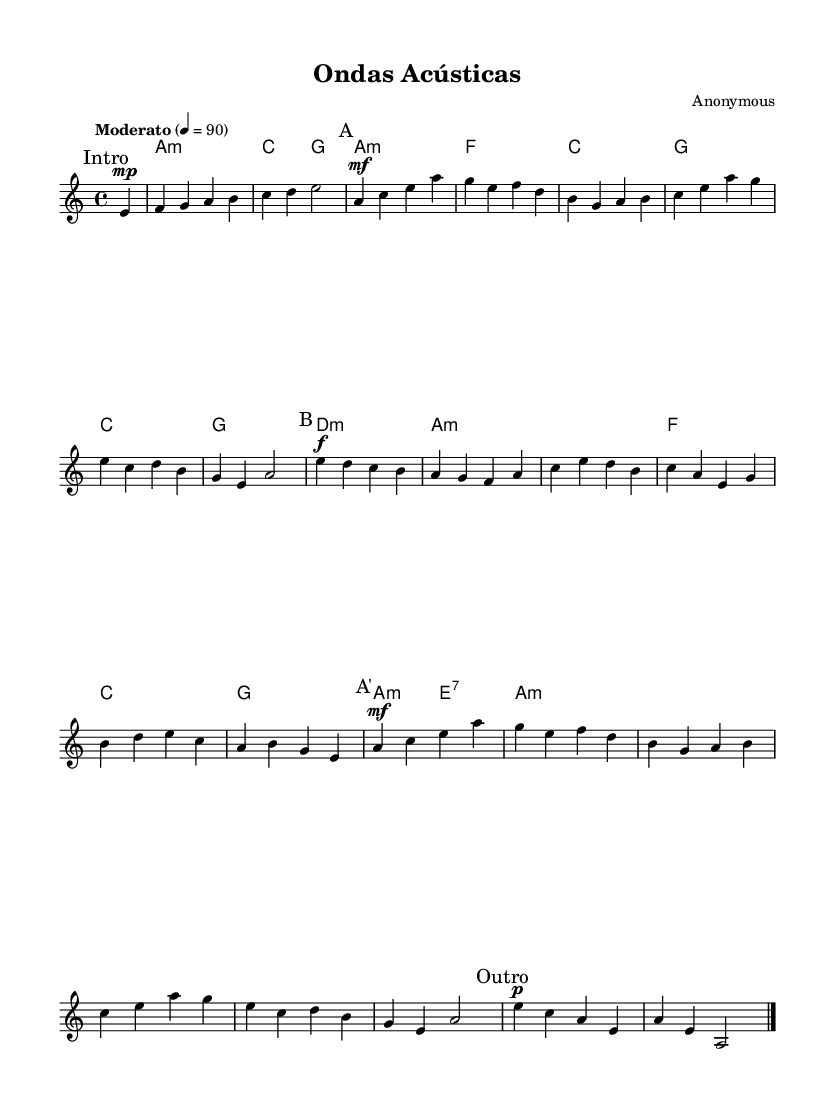What is the key signature of this music? The key signature is indicated by the use of 'a' and 'a minor' chords. There are no sharps or flats noted, confirming it is in a natural minor key.
Answer: A minor What is the time signature of this music? The time signature is found at the beginning of the sheet music where the notation '4/4' is written, which indicates there are four beats in each measure and a quarter note receives one beat.
Answer: 4/4 What is the tempo marking for this piece? The tempo marking appears as 'Moderato' followed by '4 = 90', indicating that the quarter note should be played at 90 beats per minute, which is a moderate pace.
Answer: Moderato How many sections are in the music? By examining the labels on the music, there are distinct sections marked as "Intro," "A," "B," "A'," and "Outro," indicating five sections in total.
Answer: Five What is the structure of the harmony in section B? In section B, the chords progress through a series of notes starting with e', d, c, b, a, g, followed by f, a, c, e, d, b, and continuing, showing a pattern of descending and then ascending notes, typical in Latin music.
Answer: Descending and ascending What dynamic marking is used at the beginning and end of the sections? The dynamic markings specify the volume and intensity of the music. 'mp' is used at the start marking "Intro" for a soft sound, while 'f' in section B indicates a loud sound, ending with 'p' for a softer conclusion.
Answer: mp, f, p What is the primary instrument featured in this sheet music? The music specifies a 'guitar' voice part written in the staff, emphasizing the acoustic guitar as the primary instrument for this piece.
Answer: Guitar 